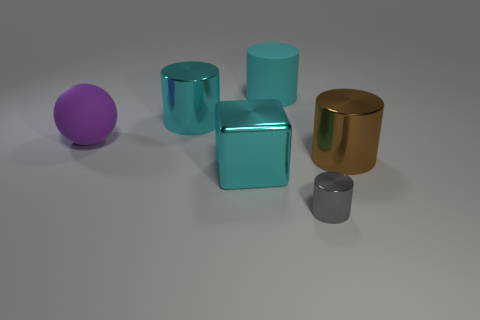Subtract all small cylinders. How many cylinders are left? 3 Add 4 brown things. How many objects exist? 10 Subtract all brown cylinders. How many cylinders are left? 3 Subtract all blocks. How many objects are left? 5 Subtract all cylinders. Subtract all small purple metallic cylinders. How many objects are left? 2 Add 3 metallic cylinders. How many metallic cylinders are left? 6 Add 2 cyan metal cylinders. How many cyan metal cylinders exist? 3 Subtract 0 green spheres. How many objects are left? 6 Subtract 1 cylinders. How many cylinders are left? 3 Subtract all blue cylinders. Subtract all yellow cubes. How many cylinders are left? 4 